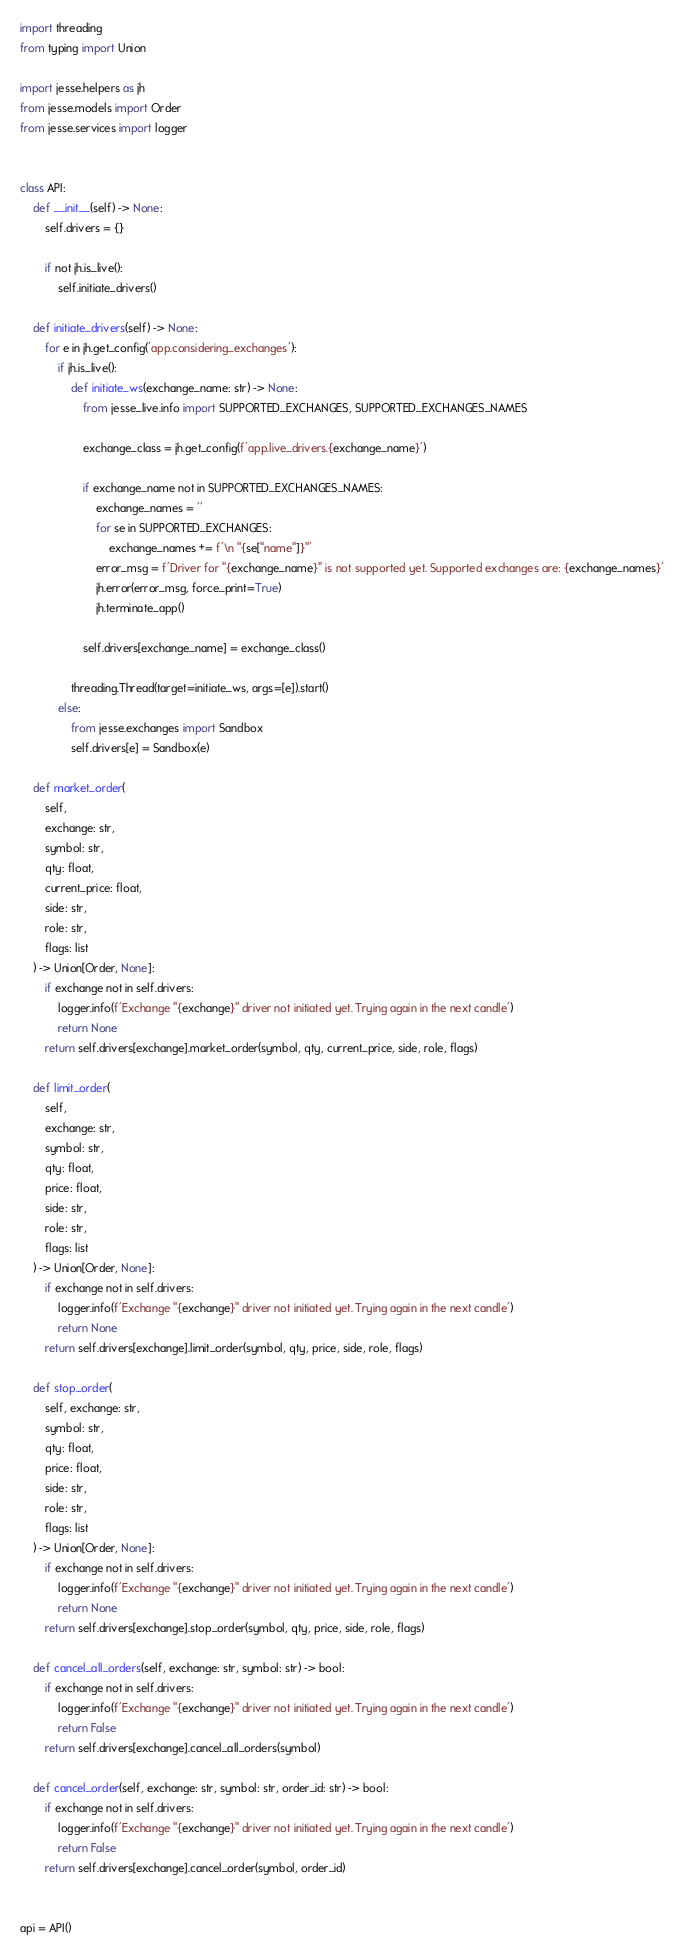Convert code to text. <code><loc_0><loc_0><loc_500><loc_500><_Python_>import threading
from typing import Union

import jesse.helpers as jh
from jesse.models import Order
from jesse.services import logger


class API:
    def __init__(self) -> None:
        self.drivers = {}

        if not jh.is_live():
            self.initiate_drivers()

    def initiate_drivers(self) -> None:
        for e in jh.get_config('app.considering_exchanges'):
            if jh.is_live():
                def initiate_ws(exchange_name: str) -> None:
                    from jesse_live.info import SUPPORTED_EXCHANGES, SUPPORTED_EXCHANGES_NAMES

                    exchange_class = jh.get_config(f'app.live_drivers.{exchange_name}')

                    if exchange_name not in SUPPORTED_EXCHANGES_NAMES:
                        exchange_names = ''
                        for se in SUPPORTED_EXCHANGES:
                            exchange_names += f'\n "{se["name"]}"'
                        error_msg = f'Driver for "{exchange_name}" is not supported yet. Supported exchanges are: {exchange_names}'
                        jh.error(error_msg, force_print=True)
                        jh.terminate_app()

                    self.drivers[exchange_name] = exchange_class()

                threading.Thread(target=initiate_ws, args=[e]).start()
            else:
                from jesse.exchanges import Sandbox
                self.drivers[e] = Sandbox(e)

    def market_order(
        self,
        exchange: str,
        symbol: str,
        qty: float,
        current_price: float,
        side: str,
        role: str,
        flags: list
    ) -> Union[Order, None]:
        if exchange not in self.drivers:
            logger.info(f'Exchange "{exchange}" driver not initiated yet. Trying again in the next candle')
            return None
        return self.drivers[exchange].market_order(symbol, qty, current_price, side, role, flags)

    def limit_order(
        self,
        exchange: str,
        symbol: str,
        qty: float,
        price: float,
        side: str,
        role: str,
        flags: list
    ) -> Union[Order, None]:
        if exchange not in self.drivers:
            logger.info(f'Exchange "{exchange}" driver not initiated yet. Trying again in the next candle')
            return None
        return self.drivers[exchange].limit_order(symbol, qty, price, side, role, flags)

    def stop_order(
        self, exchange: str,
        symbol: str,
        qty: float,
        price: float,
        side: str,
        role: str,
        flags: list
    ) -> Union[Order, None]:
        if exchange not in self.drivers:
            logger.info(f'Exchange "{exchange}" driver not initiated yet. Trying again in the next candle')
            return None
        return self.drivers[exchange].stop_order(symbol, qty, price, side, role, flags)

    def cancel_all_orders(self, exchange: str, symbol: str) -> bool:
        if exchange not in self.drivers:
            logger.info(f'Exchange "{exchange}" driver not initiated yet. Trying again in the next candle')
            return False
        return self.drivers[exchange].cancel_all_orders(symbol)

    def cancel_order(self, exchange: str, symbol: str, order_id: str) -> bool:
        if exchange not in self.drivers:
            logger.info(f'Exchange "{exchange}" driver not initiated yet. Trying again in the next candle')
            return False
        return self.drivers[exchange].cancel_order(symbol, order_id)


api = API()
</code> 